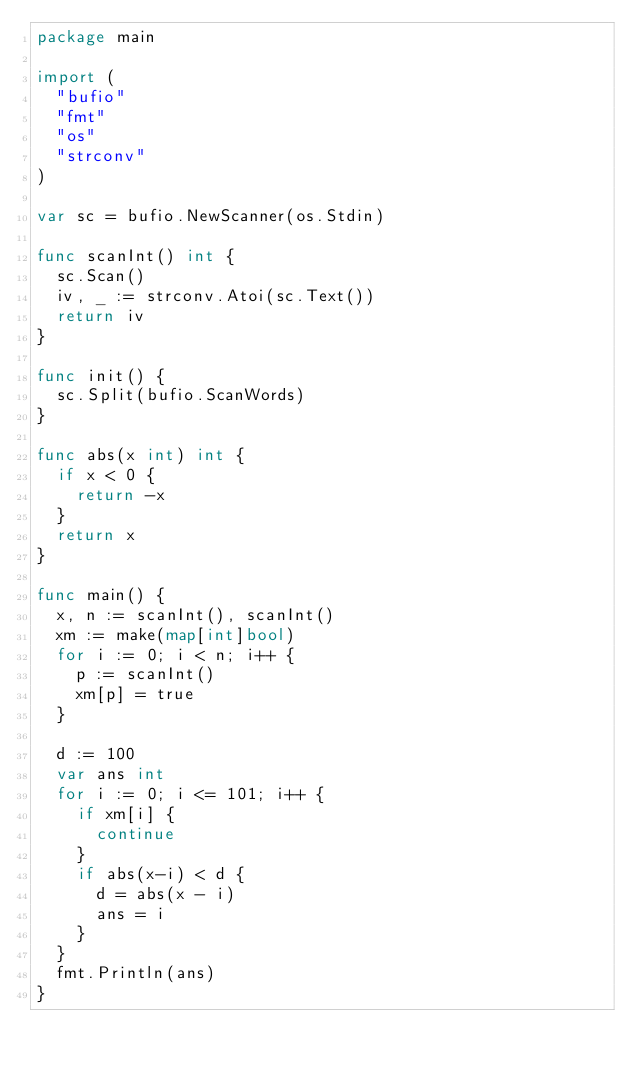Convert code to text. <code><loc_0><loc_0><loc_500><loc_500><_Go_>package main

import (
	"bufio"
	"fmt"
	"os"
	"strconv"
)

var sc = bufio.NewScanner(os.Stdin)

func scanInt() int {
	sc.Scan()
	iv, _ := strconv.Atoi(sc.Text())
	return iv
}

func init() {
	sc.Split(bufio.ScanWords)
}

func abs(x int) int {
	if x < 0 {
		return -x
	}
	return x
}

func main() {
	x, n := scanInt(), scanInt()
	xm := make(map[int]bool)
	for i := 0; i < n; i++ {
		p := scanInt()
		xm[p] = true
	}

	d := 100
	var ans int
	for i := 0; i <= 101; i++ {
		if xm[i] {
			continue
		}
		if abs(x-i) < d {
			d = abs(x - i)
			ans = i
		}
	}
	fmt.Println(ans)
}
</code> 